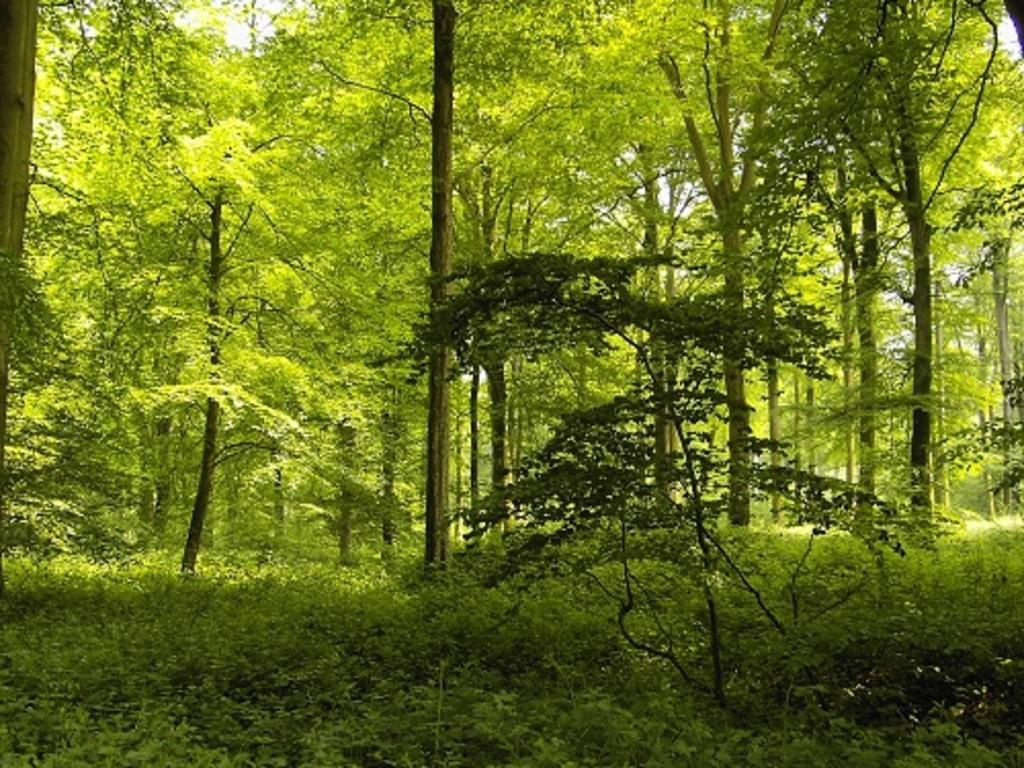Where was the image most likely taken? The image was taken in a forest or a park. What can be seen in the foreground of the picture? There are plants and trees in the foreground of the picture. What can be seen in the background of the picture? There are trees in the background of the picture. What type of substance is being used to create the horn in the image? There is no horn present in the image; it features plants and trees in a forest or park setting. 